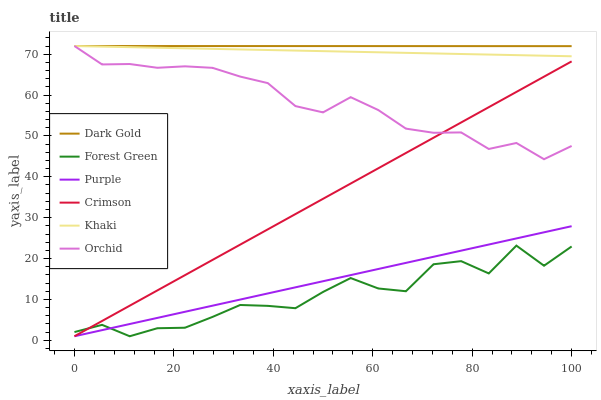Does Forest Green have the minimum area under the curve?
Answer yes or no. Yes. Does Dark Gold have the maximum area under the curve?
Answer yes or no. Yes. Does Purple have the minimum area under the curve?
Answer yes or no. No. Does Purple have the maximum area under the curve?
Answer yes or no. No. Is Purple the smoothest?
Answer yes or no. Yes. Is Forest Green the roughest?
Answer yes or no. Yes. Is Dark Gold the smoothest?
Answer yes or no. No. Is Dark Gold the roughest?
Answer yes or no. No. Does Purple have the lowest value?
Answer yes or no. Yes. Does Dark Gold have the lowest value?
Answer yes or no. No. Does Orchid have the highest value?
Answer yes or no. Yes. Does Purple have the highest value?
Answer yes or no. No. Is Forest Green less than Orchid?
Answer yes or no. Yes. Is Khaki greater than Purple?
Answer yes or no. Yes. Does Crimson intersect Purple?
Answer yes or no. Yes. Is Crimson less than Purple?
Answer yes or no. No. Is Crimson greater than Purple?
Answer yes or no. No. Does Forest Green intersect Orchid?
Answer yes or no. No. 